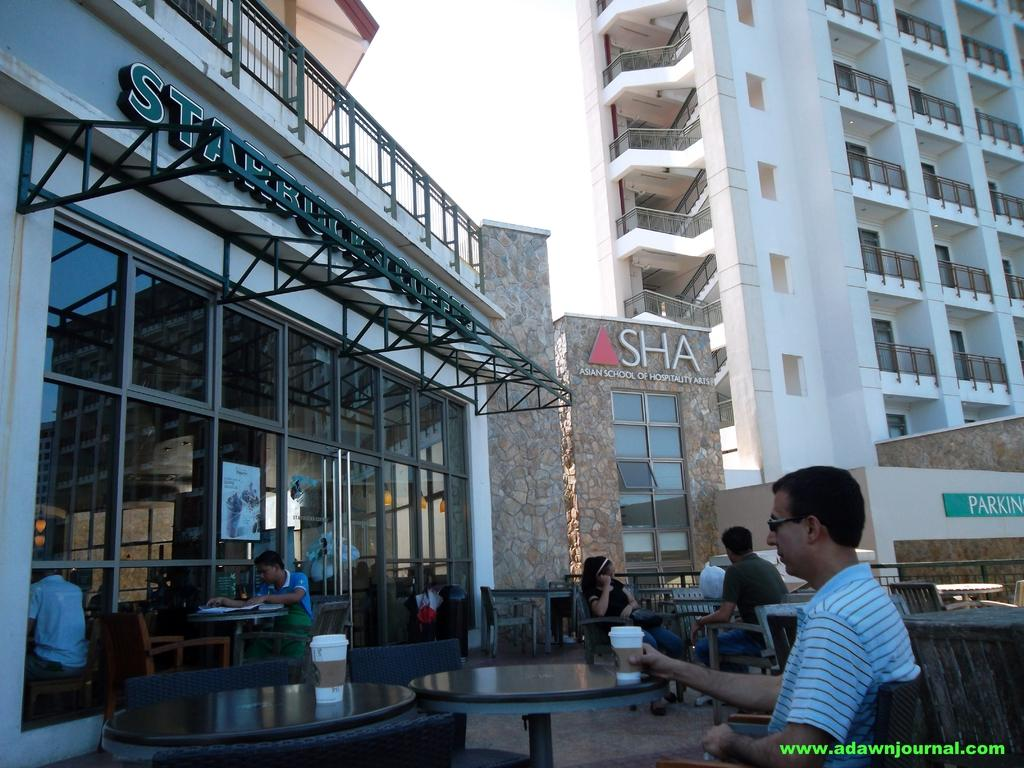What are the people in the image doing? The people in the image are sitting and drinking coffee. Where are the people sitting? They are sitting in a coffee shop. What can be seen in the background of the image? There are buildings in the background of the image. What is the condition of the sky in the image? The sky is clear in the image. What type of wool is being used to balance the tax in the image? There is no wool, balance, or tax present in the image. 